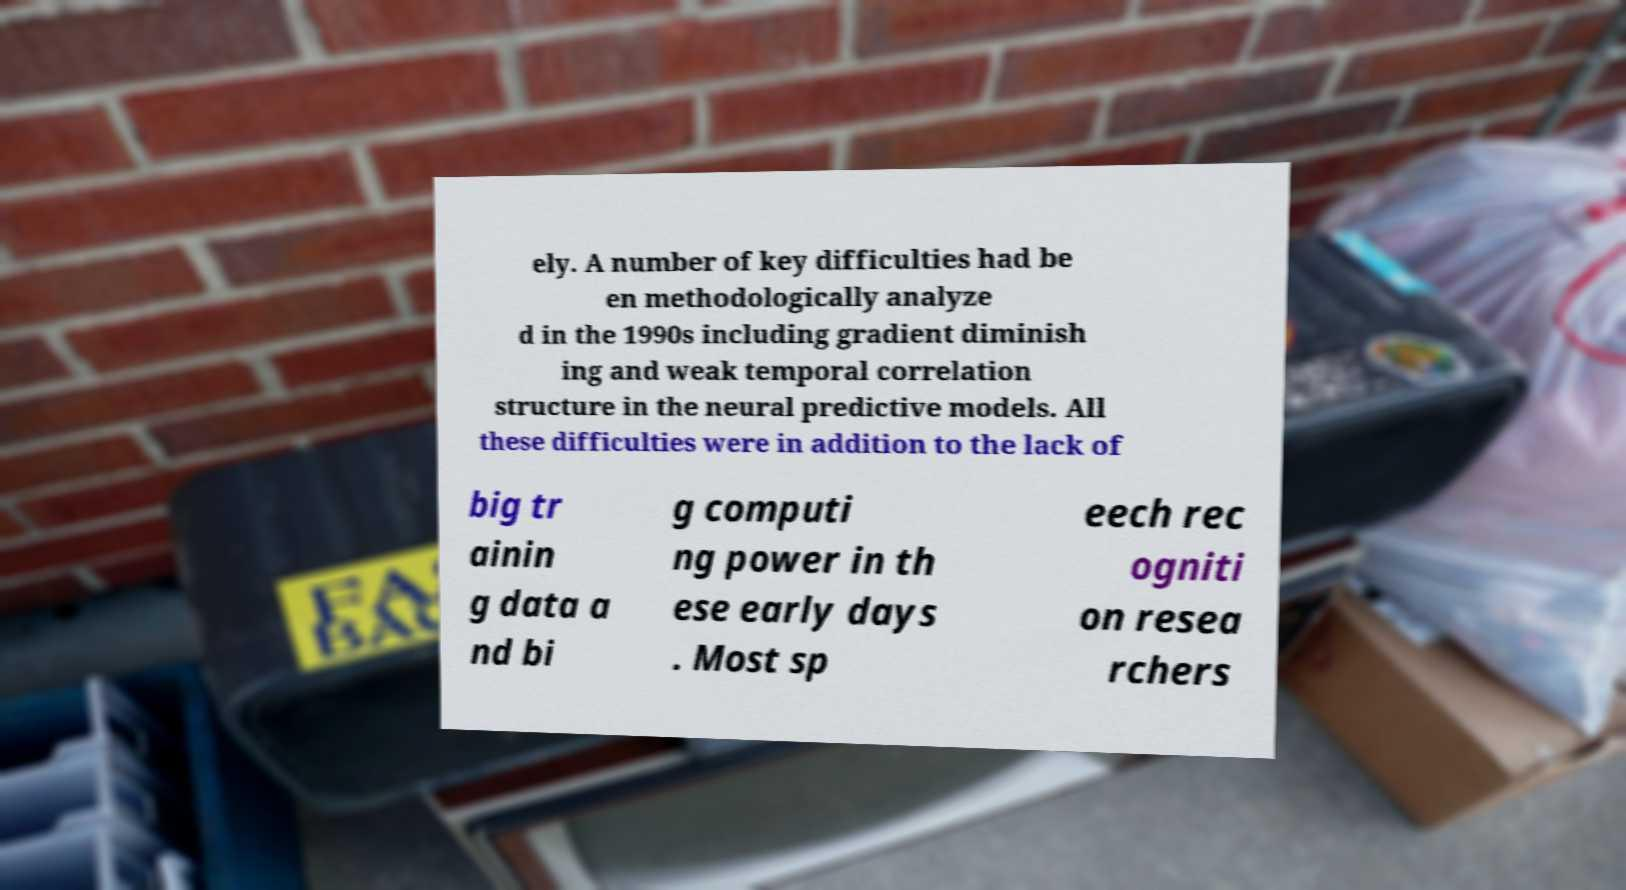For documentation purposes, I need the text within this image transcribed. Could you provide that? ely. A number of key difficulties had be en methodologically analyze d in the 1990s including gradient diminish ing and weak temporal correlation structure in the neural predictive models. All these difficulties were in addition to the lack of big tr ainin g data a nd bi g computi ng power in th ese early days . Most sp eech rec ogniti on resea rchers 